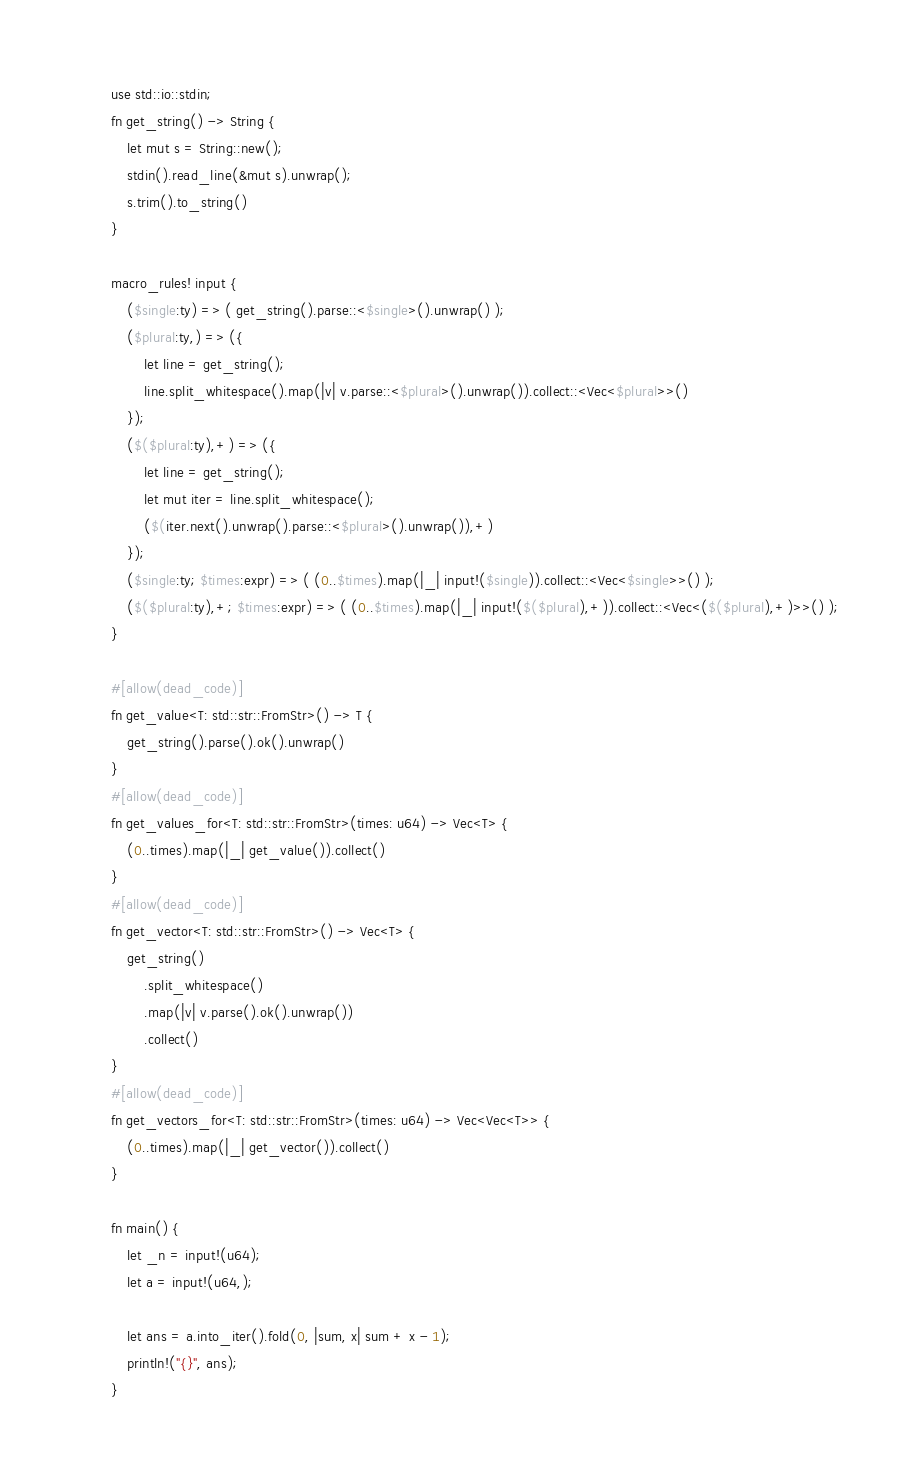<code> <loc_0><loc_0><loc_500><loc_500><_Rust_>use std::io::stdin;
fn get_string() -> String {
    let mut s = String::new();
    stdin().read_line(&mut s).unwrap();
    s.trim().to_string()
}

macro_rules! input {
    ($single:ty) => ( get_string().parse::<$single>().unwrap() );
    ($plural:ty,) => ({
        let line = get_string();
        line.split_whitespace().map(|v| v.parse::<$plural>().unwrap()).collect::<Vec<$plural>>()
    });
    ($($plural:ty),+) => ({
        let line = get_string();
        let mut iter = line.split_whitespace();
        ($(iter.next().unwrap().parse::<$plural>().unwrap()),+)
    });
    ($single:ty; $times:expr) => ( (0..$times).map(|_| input!($single)).collect::<Vec<$single>>() );
    ($($plural:ty),+; $times:expr) => ( (0..$times).map(|_| input!($($plural),+)).collect::<Vec<($($plural),+)>>() );
}

#[allow(dead_code)]
fn get_value<T: std::str::FromStr>() -> T {
    get_string().parse().ok().unwrap()
}
#[allow(dead_code)]
fn get_values_for<T: std::str::FromStr>(times: u64) -> Vec<T> {
    (0..times).map(|_| get_value()).collect()
}
#[allow(dead_code)]
fn get_vector<T: std::str::FromStr>() -> Vec<T> {
    get_string()
        .split_whitespace()
        .map(|v| v.parse().ok().unwrap())
        .collect()
}
#[allow(dead_code)]
fn get_vectors_for<T: std::str::FromStr>(times: u64) -> Vec<Vec<T>> {
    (0..times).map(|_| get_vector()).collect()
}

fn main() {
    let _n = input!(u64);
    let a = input!(u64,);

    let ans = a.into_iter().fold(0, |sum, x| sum + x - 1);
    println!("{}", ans);
}
</code> 